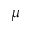Convert formula to latex. <formula><loc_0><loc_0><loc_500><loc_500>\mu</formula> 